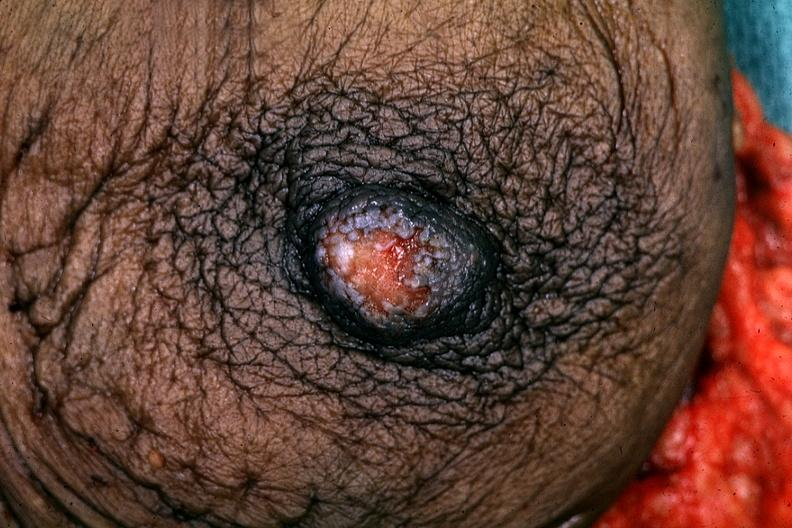s pagets disease present?
Answer the question using a single word or phrase. Yes 